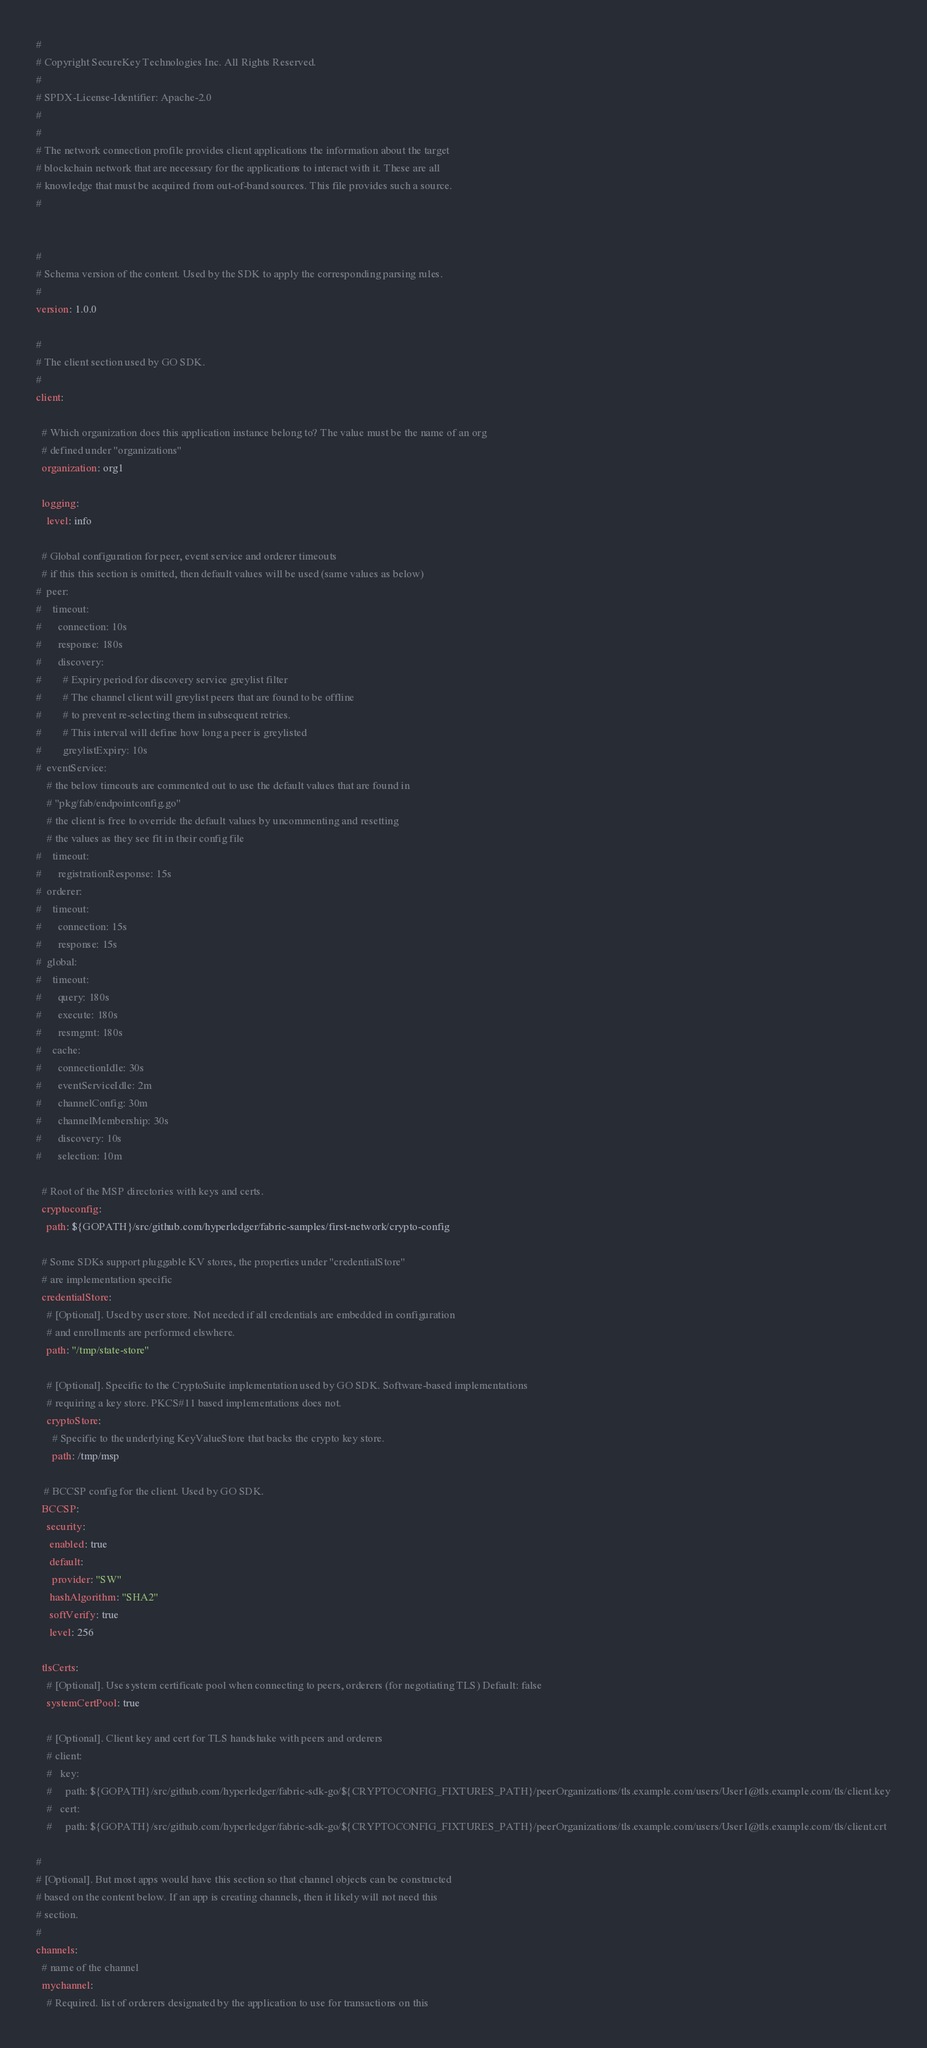Convert code to text. <code><loc_0><loc_0><loc_500><loc_500><_YAML_>#
# Copyright SecureKey Technologies Inc. All Rights Reserved.
#
# SPDX-License-Identifier: Apache-2.0
#
#
# The network connection profile provides client applications the information about the target
# blockchain network that are necessary for the applications to interact with it. These are all
# knowledge that must be acquired from out-of-band sources. This file provides such a source.
#


#
# Schema version of the content. Used by the SDK to apply the corresponding parsing rules.
#
version: 1.0.0

#
# The client section used by GO SDK.
#
client:

  # Which organization does this application instance belong to? The value must be the name of an org
  # defined under "organizations"
  organization: org1

  logging:
    level: info

  # Global configuration for peer, event service and orderer timeouts
  # if this this section is omitted, then default values will be used (same values as below)
#  peer:
#    timeout:
#      connection: 10s
#      response: 180s
#      discovery:
#        # Expiry period for discovery service greylist filter
#        # The channel client will greylist peers that are found to be offline
#        # to prevent re-selecting them in subsequent retries.
#        # This interval will define how long a peer is greylisted
#        greylistExpiry: 10s
#  eventService:
    # the below timeouts are commented out to use the default values that are found in
    # "pkg/fab/endpointconfig.go"
    # the client is free to override the default values by uncommenting and resetting
    # the values as they see fit in their config file
#    timeout:
#      registrationResponse: 15s
#  orderer:
#    timeout:
#      connection: 15s
#      response: 15s
#  global:
#    timeout:
#      query: 180s
#      execute: 180s
#      resmgmt: 180s
#    cache:
#      connectionIdle: 30s
#      eventServiceIdle: 2m
#      channelConfig: 30m
#      channelMembership: 30s
#      discovery: 10s
#      selection: 10m

  # Root of the MSP directories with keys and certs.
  cryptoconfig:
    path: ${GOPATH}/src/github.com/hyperledger/fabric-samples/first-network/crypto-config

  # Some SDKs support pluggable KV stores, the properties under "credentialStore"
  # are implementation specific
  credentialStore:
    # [Optional]. Used by user store. Not needed if all credentials are embedded in configuration
    # and enrollments are performed elswhere.
    path: "/tmp/state-store"

    # [Optional]. Specific to the CryptoSuite implementation used by GO SDK. Software-based implementations
    # requiring a key store. PKCS#11 based implementations does not.
    cryptoStore:
      # Specific to the underlying KeyValueStore that backs the crypto key store.
      path: /tmp/msp

   # BCCSP config for the client. Used by GO SDK.
  BCCSP:
    security:
     enabled: true
     default:
      provider: "SW"
     hashAlgorithm: "SHA2"
     softVerify: true
     level: 256

  tlsCerts:
    # [Optional]. Use system certificate pool when connecting to peers, orderers (for negotiating TLS) Default: false
    systemCertPool: true

    # [Optional]. Client key and cert for TLS handshake with peers and orderers
    # client:
    #   key:
    #     path: ${GOPATH}/src/github.com/hyperledger/fabric-sdk-go/${CRYPTOCONFIG_FIXTURES_PATH}/peerOrganizations/tls.example.com/users/User1@tls.example.com/tls/client.key
    #   cert:
    #     path: ${GOPATH}/src/github.com/hyperledger/fabric-sdk-go/${CRYPTOCONFIG_FIXTURES_PATH}/peerOrganizations/tls.example.com/users/User1@tls.example.com/tls/client.crt

#
# [Optional]. But most apps would have this section so that channel objects can be constructed
# based on the content below. If an app is creating channels, then it likely will not need this
# section.
#
channels:
  # name of the channel
  mychannel:
    # Required. list of orderers designated by the application to use for transactions on this</code> 